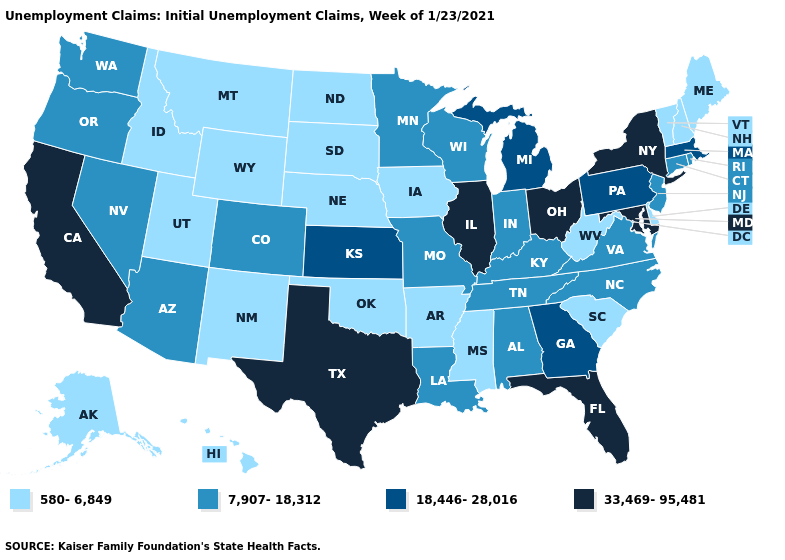What is the lowest value in the USA?
Short answer required. 580-6,849. What is the value of Virginia?
Quick response, please. 7,907-18,312. Among the states that border Massachusetts , does New York have the highest value?
Write a very short answer. Yes. Name the states that have a value in the range 18,446-28,016?
Quick response, please. Georgia, Kansas, Massachusetts, Michigan, Pennsylvania. Name the states that have a value in the range 580-6,849?
Give a very brief answer. Alaska, Arkansas, Delaware, Hawaii, Idaho, Iowa, Maine, Mississippi, Montana, Nebraska, New Hampshire, New Mexico, North Dakota, Oklahoma, South Carolina, South Dakota, Utah, Vermont, West Virginia, Wyoming. What is the value of Delaware?
Short answer required. 580-6,849. Among the states that border Oklahoma , does Kansas have the lowest value?
Be succinct. No. Does Washington have the same value as Ohio?
Keep it brief. No. What is the lowest value in the USA?
Answer briefly. 580-6,849. Name the states that have a value in the range 580-6,849?
Answer briefly. Alaska, Arkansas, Delaware, Hawaii, Idaho, Iowa, Maine, Mississippi, Montana, Nebraska, New Hampshire, New Mexico, North Dakota, Oklahoma, South Carolina, South Dakota, Utah, Vermont, West Virginia, Wyoming. Among the states that border Iowa , does Minnesota have the lowest value?
Keep it brief. No. What is the highest value in the USA?
Give a very brief answer. 33,469-95,481. Does North Dakota have the same value as Montana?
Write a very short answer. Yes. Does Iowa have the lowest value in the USA?
Be succinct. Yes. Does Missouri have the lowest value in the USA?
Keep it brief. No. 